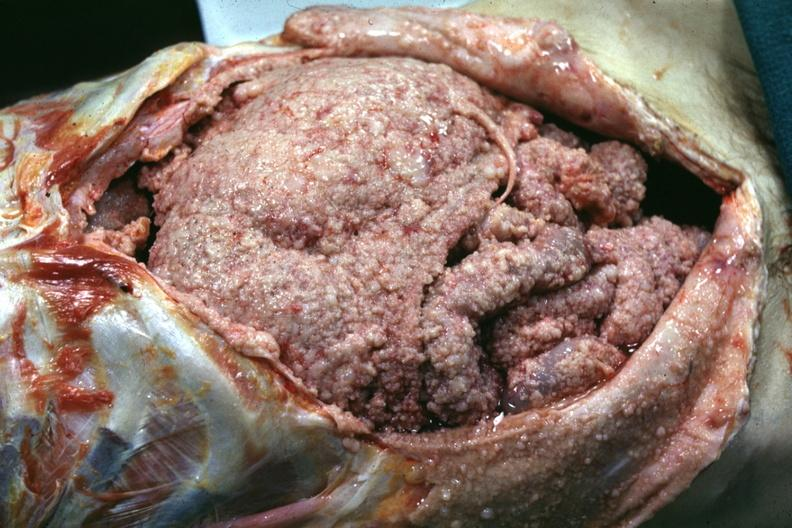s abdomen present?
Answer the question using a single word or phrase. Yes 